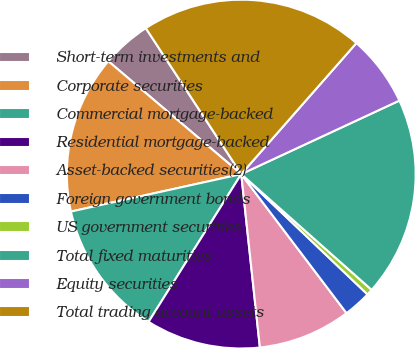Convert chart. <chart><loc_0><loc_0><loc_500><loc_500><pie_chart><fcel>Short-term investments and<fcel>Corporate securities<fcel>Commercial mortgage-backed<fcel>Residential mortgage-backed<fcel>Asset-backed securities(2)<fcel>Foreign government bonds<fcel>US government securities<fcel>Total fixed maturities<fcel>Equity securities<fcel>Total trading account assets<nl><fcel>4.58%<fcel>14.65%<fcel>12.64%<fcel>10.62%<fcel>8.61%<fcel>2.57%<fcel>0.56%<fcel>18.48%<fcel>6.6%<fcel>20.69%<nl></chart> 